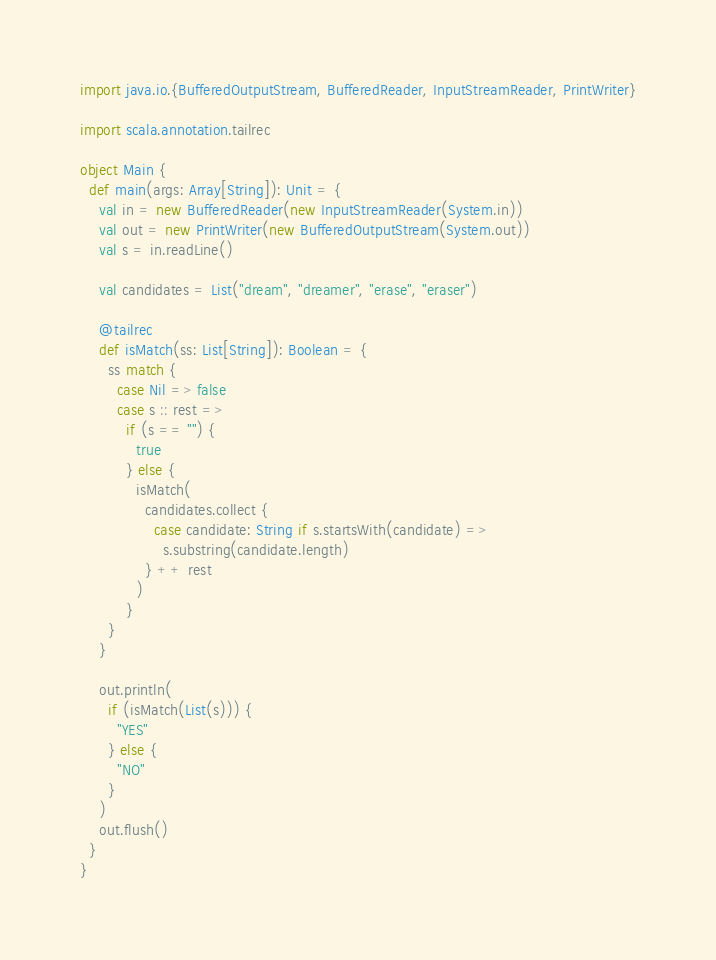Convert code to text. <code><loc_0><loc_0><loc_500><loc_500><_Scala_>import java.io.{BufferedOutputStream, BufferedReader, InputStreamReader, PrintWriter}

import scala.annotation.tailrec

object Main {
  def main(args: Array[String]): Unit = {
    val in = new BufferedReader(new InputStreamReader(System.in))
    val out = new PrintWriter(new BufferedOutputStream(System.out))
    val s = in.readLine()

    val candidates = List("dream", "dreamer", "erase", "eraser")

    @tailrec
    def isMatch(ss: List[String]): Boolean = {
      ss match {
        case Nil => false
        case s :: rest =>
          if (s == "") {
            true
          } else {
            isMatch(
              candidates.collect {
                case candidate: String if s.startsWith(candidate) =>
                  s.substring(candidate.length)
              } ++ rest
            )
          }
      }
    }

    out.println(
      if (isMatch(List(s))) {
        "YES"
      } else {
        "NO"
      }
    )
    out.flush()
  }
}
</code> 